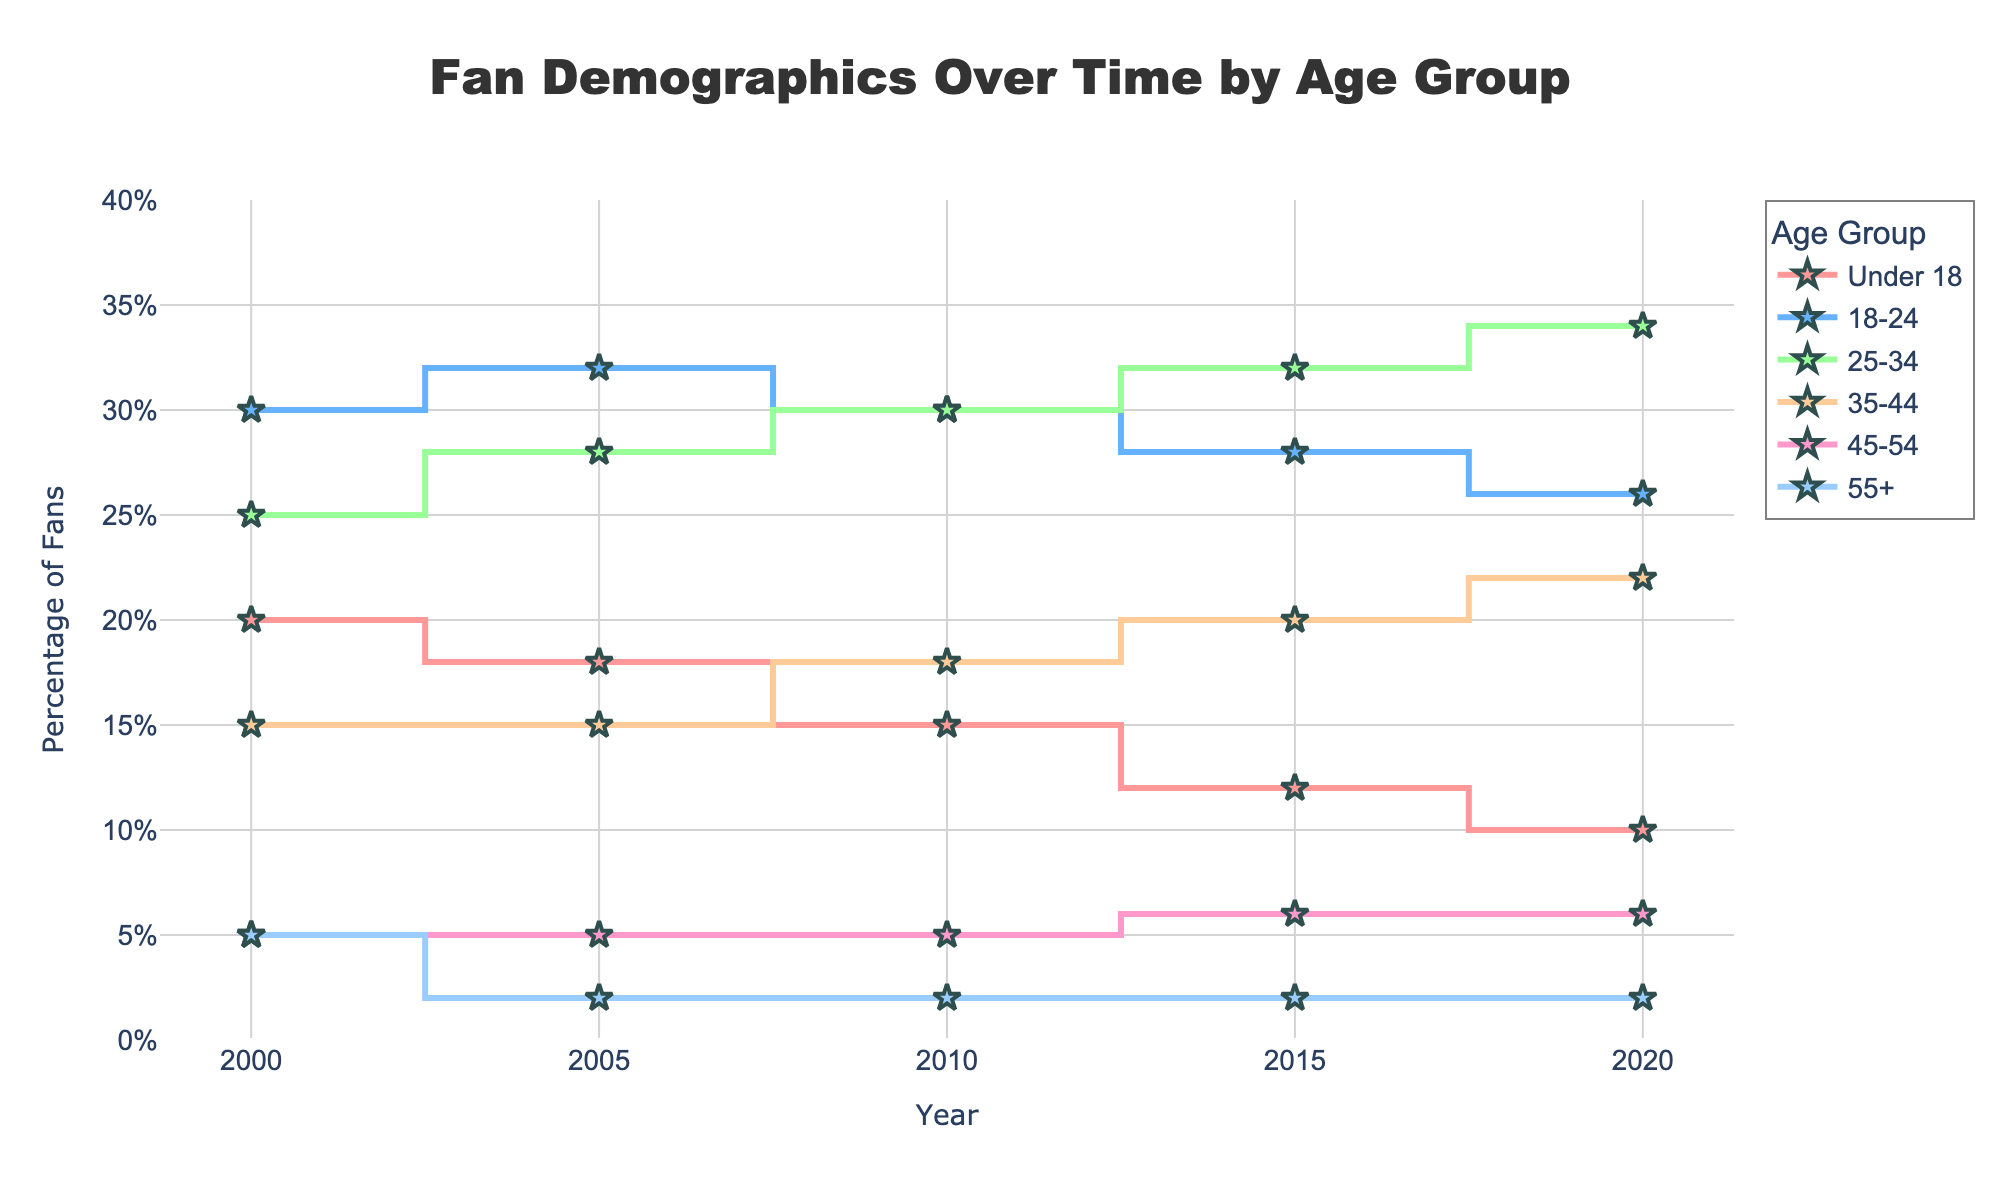what is the title of the figure? The title is displayed at the top center of the figure in large, bolded text. It summarizes the content of the chart which is about the distribution of fan demographics over time by different age groups.
Answer: Fan Demographics Over Time by Age Group which age group had the highest percentage of fans in 2000? Look at the data points for the year 2000 and identify which age group corresponds to the highest position on the y-axis.
Answer: 18-24 how did the percentage of fans for the "Under 18" age group change from 2000 to 2020? Identify the data points for the "Under 18" age group in the years 2000 and 2020, and then calculate the difference.
Answer: Decreased by 10% what is the sum of percentages for the age groups "25-34" and "35-44" in 2010? Find the data points for the "25-34" and "35-44" age groups in 2010, and sum their values.
Answer: 48% was there any age group that consistently had the lowest percentage of fans in all the years shown? Inspect the data points for all age groups across all years, then identify the one that is consistently at the bottom.
Answer: 55+ how did the fan base of the "25-34" age group change from 2000 to 2020? Identify the data points for the "25-34" age group in both 2000 and 2020, and note the difference and trend over time.
Answer: Increased by 9% what are the colors used for the lines representing different age groups? Look at the lines in the plot and note the different colors used for each age group.
Answer: Varying shades of red, blue, green, and orange tones between 2010 and 2020, which age group showed the greatest increase in the percentage of fans? Calculate the percentage difference for each age group between 2010 and 2020, then identify the one with the highest increase.
Answer: 35-44 in 2020, which two age groups had the closest percentages of fans? Look at the data for 2020 and compare the percentages to identify the two age groups whose values are most similar.
Answer: 45-54 and 55+ which year had the highest overall percentage of fans for the "18-24" age group? Evaluate the data points for the "18-24" age group across all years and identify the one with the highest value.
Answer: 2005 